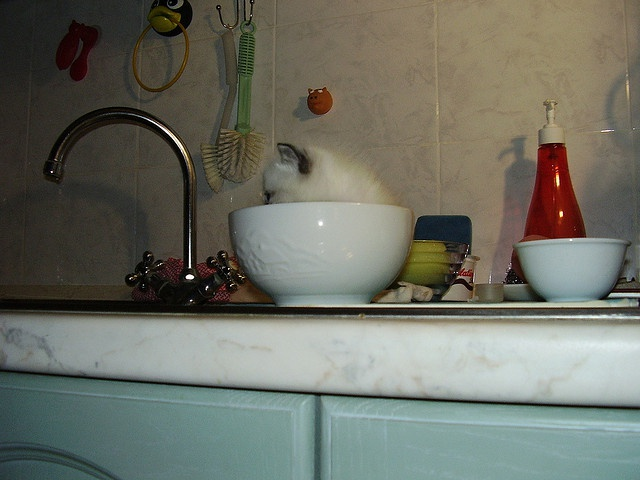Describe the objects in this image and their specific colors. I can see sink in black, darkgray, lightgray, and gray tones, bowl in black, darkgray, and gray tones, cat in black, darkgray, and gray tones, dog in black, darkgray, and gray tones, and bowl in black, darkgray, and gray tones in this image. 